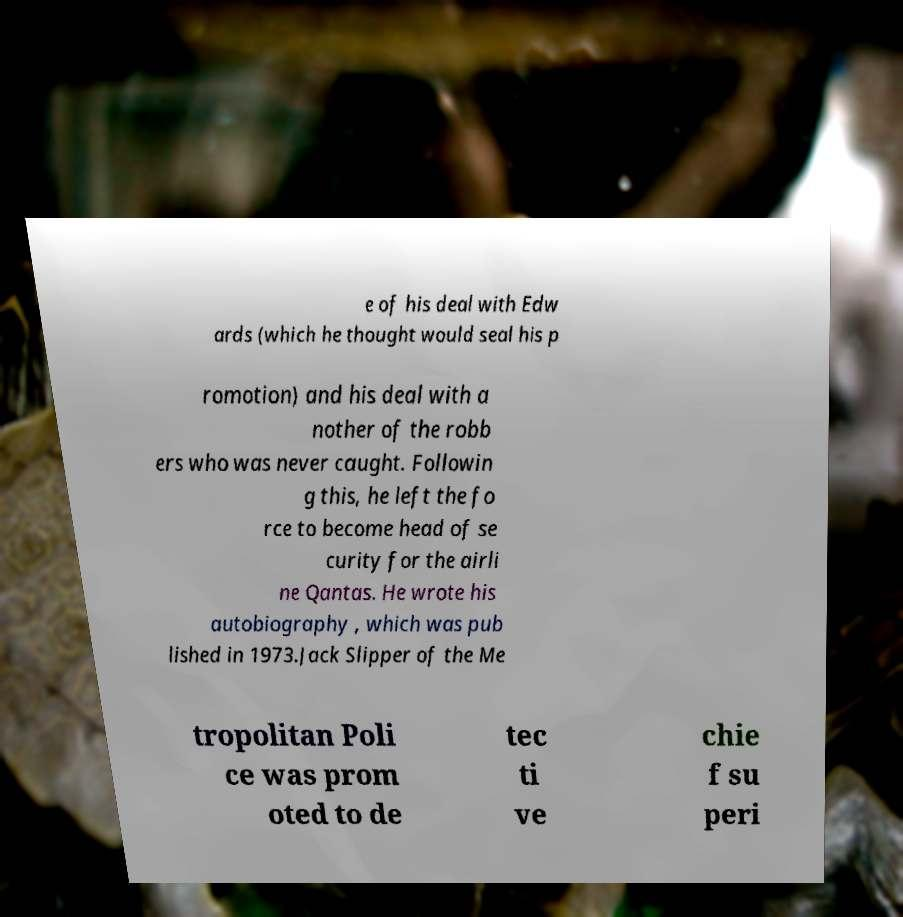Can you read and provide the text displayed in the image?This photo seems to have some interesting text. Can you extract and type it out for me? e of his deal with Edw ards (which he thought would seal his p romotion) and his deal with a nother of the robb ers who was never caught. Followin g this, he left the fo rce to become head of se curity for the airli ne Qantas. He wrote his autobiography , which was pub lished in 1973.Jack Slipper of the Me tropolitan Poli ce was prom oted to de tec ti ve chie f su peri 